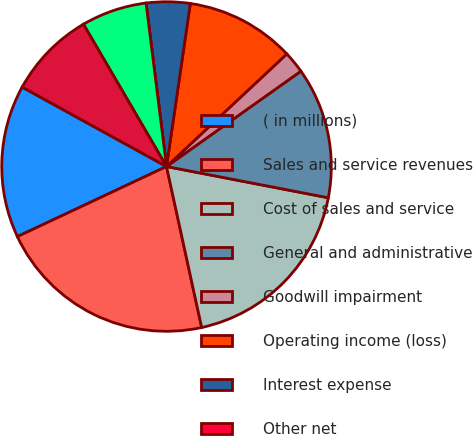<chart> <loc_0><loc_0><loc_500><loc_500><pie_chart><fcel>( in millions)<fcel>Sales and service revenues<fcel>Cost of sales and service<fcel>General and administrative<fcel>Goodwill impairment<fcel>Operating income (loss)<fcel>Interest expense<fcel>Other net<fcel>Federal and foreign income<fcel>Net earnings (loss)<nl><fcel>15.0%<fcel>21.43%<fcel>18.54%<fcel>12.86%<fcel>2.15%<fcel>10.72%<fcel>4.29%<fcel>0.0%<fcel>6.43%<fcel>8.58%<nl></chart> 